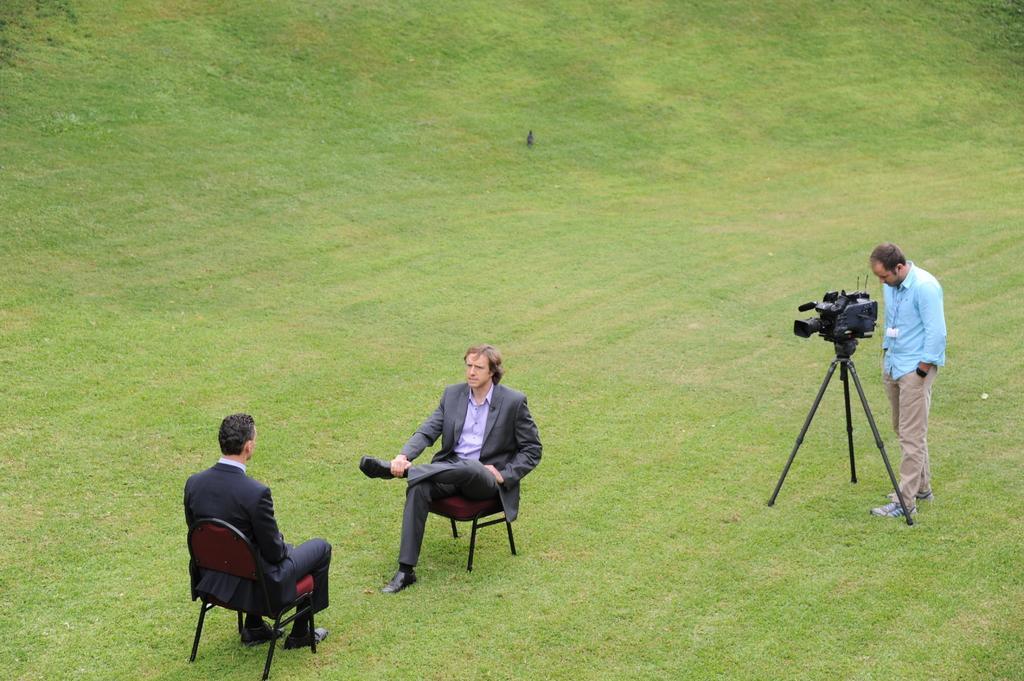How would you summarize this image in a sentence or two? In this picture here we see 2 people who are sitting on chairs, one in front of the other, looks like an interview is going on. In the right we have another person who is behind a camera and he is looking into the camera. The back part is ground. It looks like an open area. 